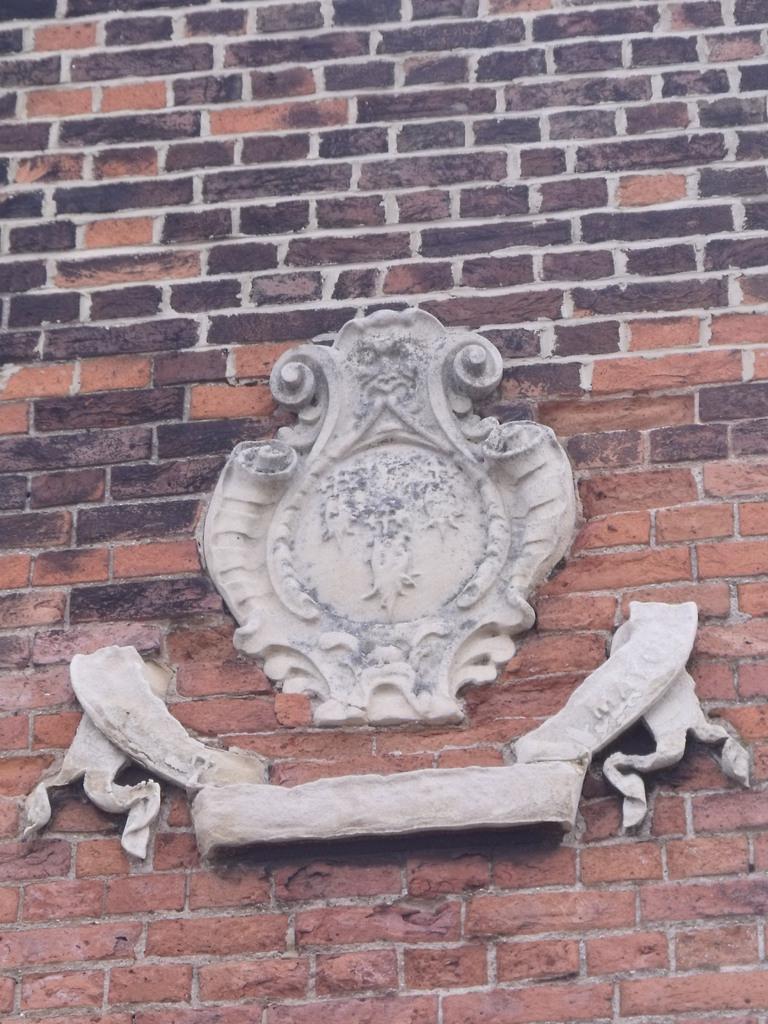Can you describe this image briefly? In this image we can see a sculpture to the brick wall. 